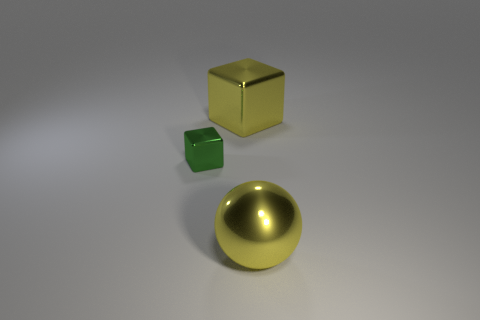What is the material of the object that is on the right side of the tiny block and in front of the big yellow shiny block?
Ensure brevity in your answer.  Metal. The large ball has what color?
Your answer should be very brief. Yellow. How many big things have the same shape as the small object?
Make the answer very short. 1. What size is the metal cube left of the cube on the right side of the green cube?
Your answer should be very brief. Small. Is there any other thing that is the same size as the green cube?
Offer a terse response. No. There is another yellow thing that is the same shape as the tiny shiny object; what is it made of?
Offer a very short reply. Metal. Does the big yellow metallic object that is behind the large yellow ball have the same shape as the big yellow thing that is in front of the green thing?
Provide a short and direct response. No. Is the number of cubes greater than the number of green things?
Your answer should be compact. Yes. What is the size of the yellow block?
Provide a short and direct response. Large. What number of other things are the same color as the big cube?
Your answer should be compact. 1. 